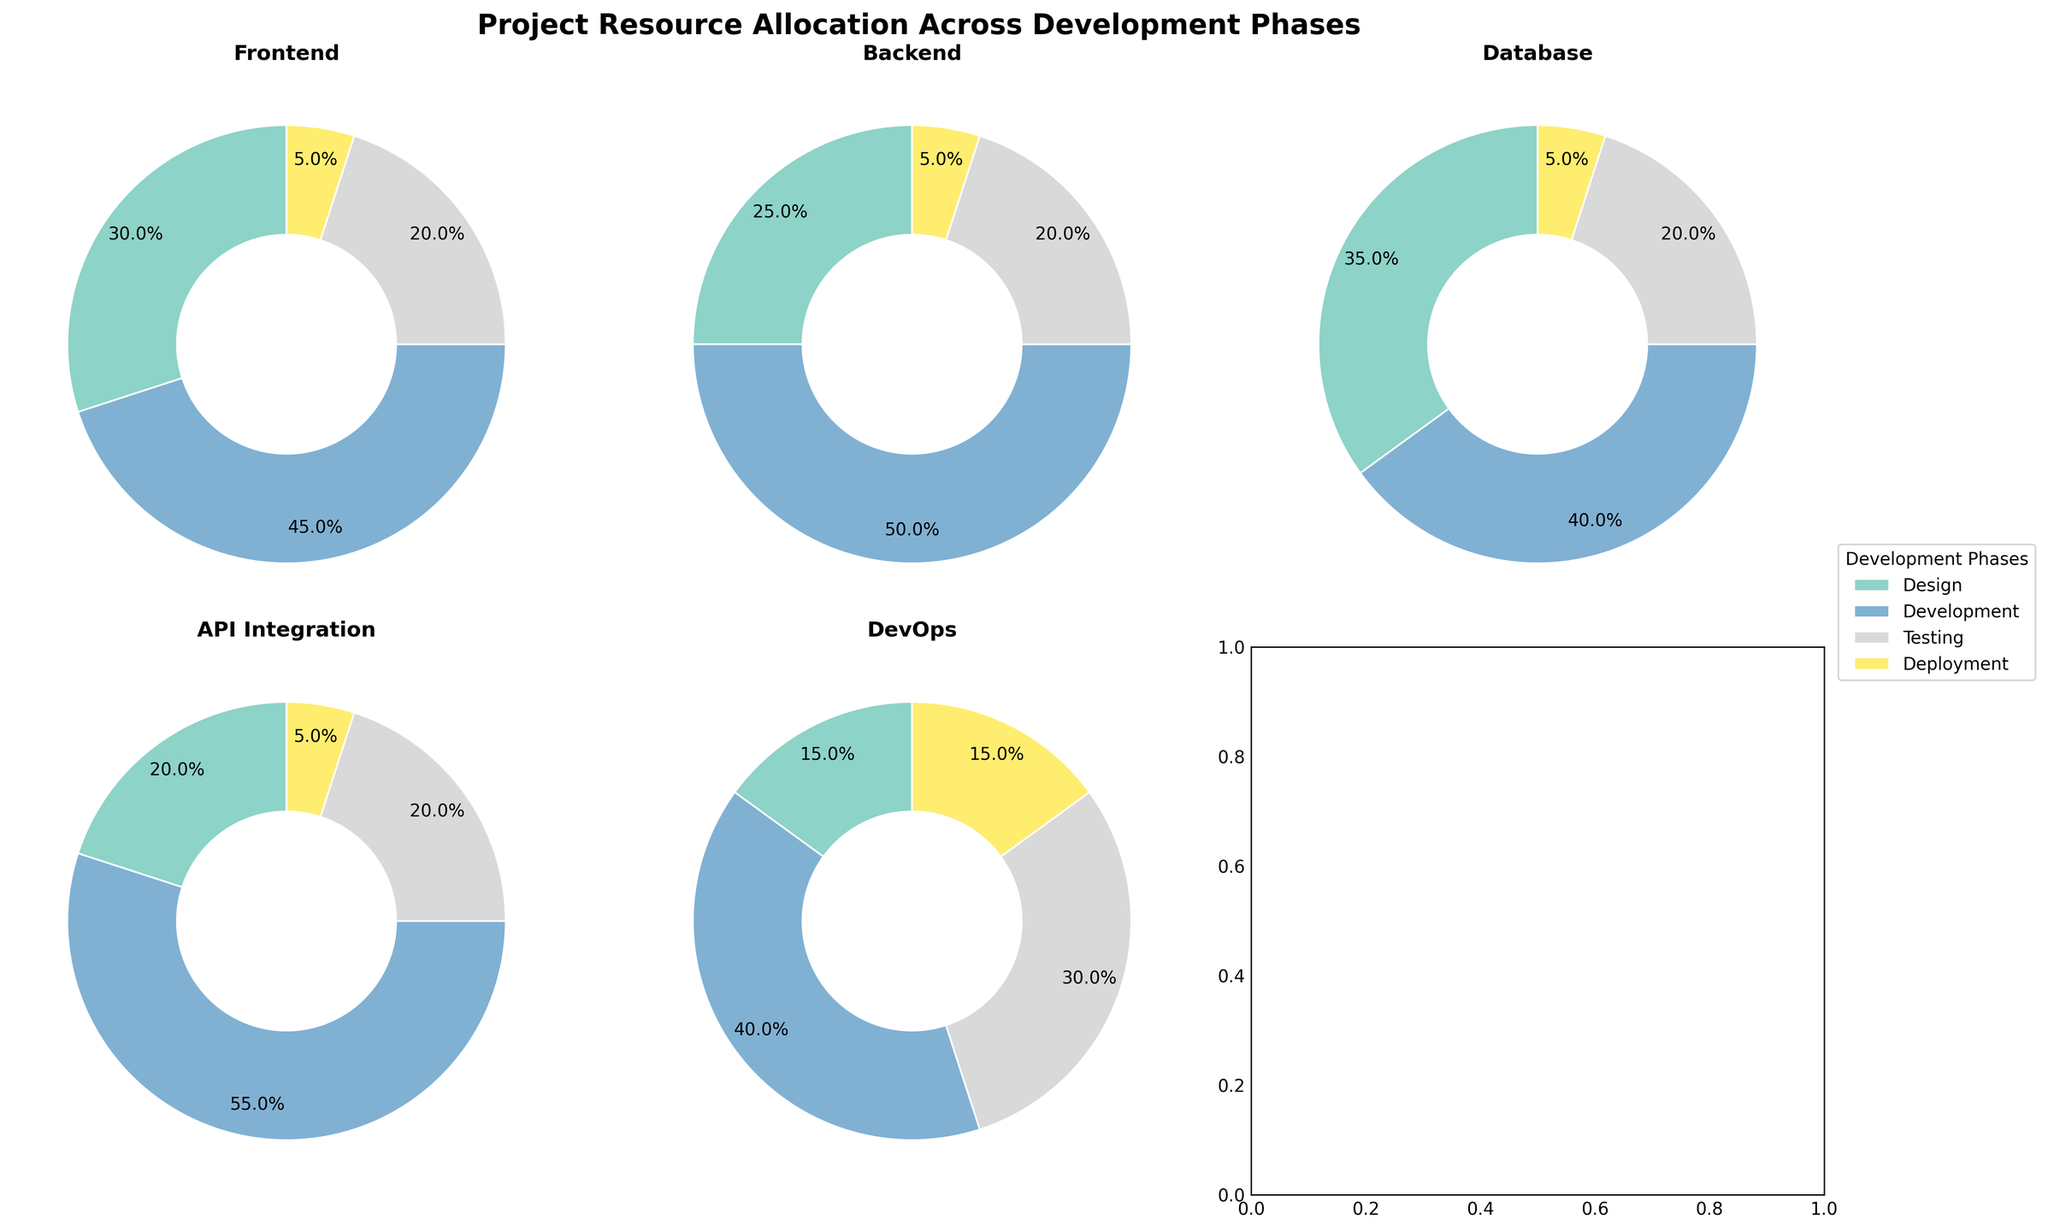what is the title of the figure? The title of a figure is typically displayed at the top. For this figure, it states the main topic being visualized.
Answer: Project Resource Allocation Across Development Phases which phase has the highest percentage of allocation in the 'Development' category? By examining the pie charts, look for the segment labeled 'Development' in each phase. Identify the phase where this segment takes up the largest portion.
Answer: API Integration what is the percentage of allocation to the 'Testing' category in the Backend phase? Locate the pie chart for the Backend phase and identify the segment labeled 'Testing'. The percentage is labeled on that segment.
Answer: 20% compare the 'Deployment' allocation between Frontend and DevOps phases. Which one is higher and by how much? Find the 'Deployment' segments of the Frontend and DevOps phases. The segments are labeled with their percentages. Calculate the difference between these two values.
Answer: DevOps is higher by 10% what is the average percentage of the 'Design' category across all phases? Add the percentages of the 'Design' category for all phases: 30 (Frontend) + 25 (Backend) + 35 (Database) + 20 (API Integration) + 15 (DevOps). Then, divide by the number of phases (5) to find the average.
Answer: 25% in which phase does 'Development' take more than 50% of the allocation? Inspect the pie charts to find the segment labeled 'Development'. Identify the chart where this segment exceeds 50%.
Answer: API Integration which category has the least variation in allocation across all phases? Compare the percentages of each category across all phases. The category with the least range (difference between max and min) has the least variation.
Answer: Testing in the DevOps phase, which category has the highest allocation? Look at the pie chart for the DevOps phase and identify the segment with the largest percentage.
Answer: Development how does the 'Design' allocation in the Database phase compare to the Frontend phase? Locate the pie charts for the Database and Frontend phases. Compare the segments labeled 'Design' to see which one is higher and by how much.
Answer: Database is higher by 5% what percentage of total allocation do 'Testing' and 'Deployment' together represent in the API Integration phase? In the API Integration phase pie chart, add the percentages for 'Testing' and 'Deployment' segments together.
Answer: 25% 